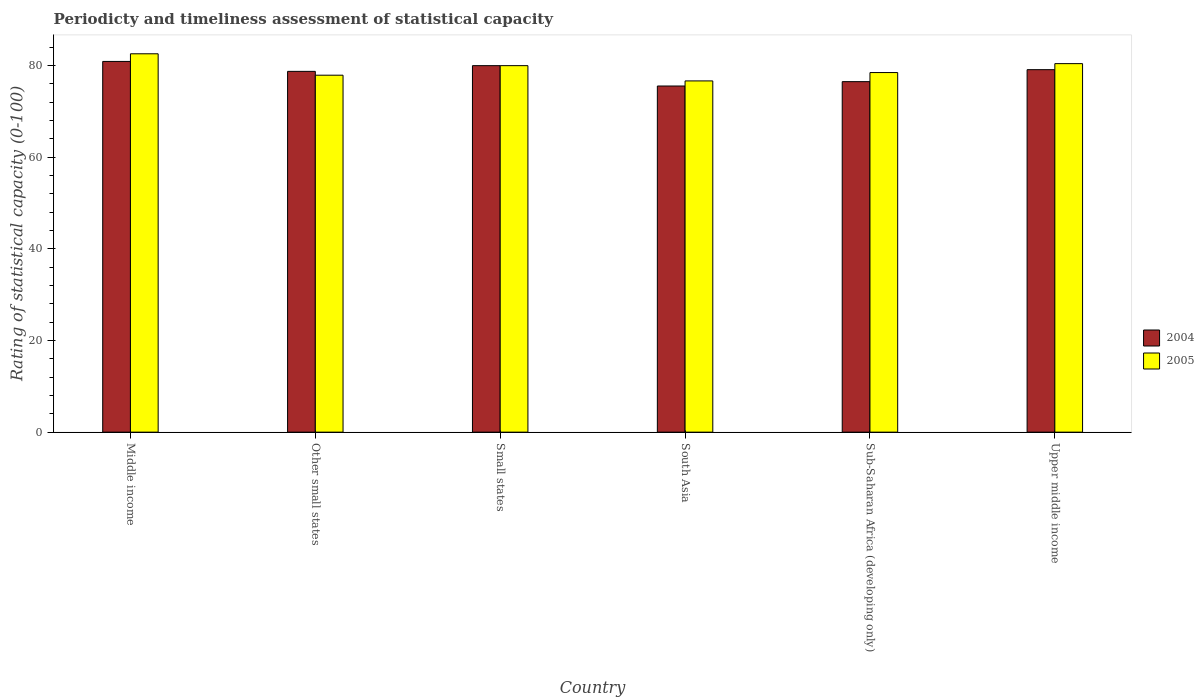How many different coloured bars are there?
Your response must be concise. 2. How many groups of bars are there?
Your answer should be very brief. 6. Are the number of bars per tick equal to the number of legend labels?
Offer a very short reply. Yes. Are the number of bars on each tick of the X-axis equal?
Provide a short and direct response. Yes. How many bars are there on the 1st tick from the right?
Provide a short and direct response. 2. What is the label of the 3rd group of bars from the left?
Give a very brief answer. Small states. What is the rating of statistical capacity in 2004 in Upper middle income?
Offer a very short reply. 79.12. Across all countries, what is the maximum rating of statistical capacity in 2004?
Ensure brevity in your answer.  80.92. Across all countries, what is the minimum rating of statistical capacity in 2005?
Ensure brevity in your answer.  76.67. In which country was the rating of statistical capacity in 2004 maximum?
Ensure brevity in your answer.  Middle income. In which country was the rating of statistical capacity in 2005 minimum?
Make the answer very short. South Asia. What is the total rating of statistical capacity in 2005 in the graph?
Your answer should be compact. 476.1. What is the difference between the rating of statistical capacity in 2004 in Small states and that in South Asia?
Ensure brevity in your answer.  4.44. What is the difference between the rating of statistical capacity in 2005 in Middle income and the rating of statistical capacity in 2004 in Small states?
Keep it short and to the point. 2.59. What is the average rating of statistical capacity in 2004 per country?
Your response must be concise. 78.48. What is the difference between the rating of statistical capacity of/in 2005 and rating of statistical capacity of/in 2004 in Small states?
Offer a very short reply. -9.999999974752427e-7. What is the ratio of the rating of statistical capacity in 2004 in Sub-Saharan Africa (developing only) to that in Upper middle income?
Your answer should be very brief. 0.97. Is the difference between the rating of statistical capacity in 2005 in Other small states and South Asia greater than the difference between the rating of statistical capacity in 2004 in Other small states and South Asia?
Provide a succinct answer. No. What is the difference between the highest and the second highest rating of statistical capacity in 2005?
Keep it short and to the point. -2.15. What is the difference between the highest and the lowest rating of statistical capacity in 2005?
Your answer should be very brief. 5.92. What does the 2nd bar from the left in Other small states represents?
Offer a terse response. 2005. How many bars are there?
Your answer should be compact. 12. Are all the bars in the graph horizontal?
Your answer should be very brief. No. How many countries are there in the graph?
Your answer should be compact. 6. Are the values on the major ticks of Y-axis written in scientific E-notation?
Your response must be concise. No. Does the graph contain any zero values?
Offer a very short reply. No. Does the graph contain grids?
Offer a terse response. No. Where does the legend appear in the graph?
Your answer should be very brief. Center right. How many legend labels are there?
Make the answer very short. 2. How are the legend labels stacked?
Your answer should be very brief. Vertical. What is the title of the graph?
Your answer should be compact. Periodicty and timeliness assessment of statistical capacity. Does "2002" appear as one of the legend labels in the graph?
Offer a terse response. No. What is the label or title of the Y-axis?
Keep it short and to the point. Rating of statistical capacity (0-100). What is the Rating of statistical capacity (0-100) of 2004 in Middle income?
Give a very brief answer. 80.92. What is the Rating of statistical capacity (0-100) in 2005 in Middle income?
Provide a succinct answer. 82.59. What is the Rating of statistical capacity (0-100) of 2004 in Other small states?
Your response must be concise. 78.75. What is the Rating of statistical capacity (0-100) in 2005 in Other small states?
Offer a very short reply. 77.92. What is the Rating of statistical capacity (0-100) of 2005 in Small states?
Keep it short and to the point. 80. What is the Rating of statistical capacity (0-100) in 2004 in South Asia?
Provide a succinct answer. 75.56. What is the Rating of statistical capacity (0-100) of 2005 in South Asia?
Give a very brief answer. 76.67. What is the Rating of statistical capacity (0-100) of 2004 in Sub-Saharan Africa (developing only)?
Your response must be concise. 76.51. What is the Rating of statistical capacity (0-100) in 2005 in Sub-Saharan Africa (developing only)?
Your response must be concise. 78.49. What is the Rating of statistical capacity (0-100) of 2004 in Upper middle income?
Provide a succinct answer. 79.12. What is the Rating of statistical capacity (0-100) in 2005 in Upper middle income?
Keep it short and to the point. 80.44. Across all countries, what is the maximum Rating of statistical capacity (0-100) in 2004?
Make the answer very short. 80.92. Across all countries, what is the maximum Rating of statistical capacity (0-100) in 2005?
Make the answer very short. 82.59. Across all countries, what is the minimum Rating of statistical capacity (0-100) of 2004?
Provide a succinct answer. 75.56. Across all countries, what is the minimum Rating of statistical capacity (0-100) in 2005?
Give a very brief answer. 76.67. What is the total Rating of statistical capacity (0-100) in 2004 in the graph?
Offer a very short reply. 470.86. What is the total Rating of statistical capacity (0-100) of 2005 in the graph?
Keep it short and to the point. 476.1. What is the difference between the Rating of statistical capacity (0-100) in 2004 in Middle income and that in Other small states?
Offer a terse response. 2.17. What is the difference between the Rating of statistical capacity (0-100) of 2005 in Middle income and that in Other small states?
Provide a short and direct response. 4.67. What is the difference between the Rating of statistical capacity (0-100) in 2004 in Middle income and that in Small states?
Offer a terse response. 0.92. What is the difference between the Rating of statistical capacity (0-100) of 2005 in Middle income and that in Small states?
Your answer should be compact. 2.59. What is the difference between the Rating of statistical capacity (0-100) in 2004 in Middle income and that in South Asia?
Keep it short and to the point. 5.37. What is the difference between the Rating of statistical capacity (0-100) of 2005 in Middle income and that in South Asia?
Your answer should be compact. 5.92. What is the difference between the Rating of statistical capacity (0-100) of 2004 in Middle income and that in Sub-Saharan Africa (developing only)?
Keep it short and to the point. 4.41. What is the difference between the Rating of statistical capacity (0-100) of 2005 in Middle income and that in Sub-Saharan Africa (developing only)?
Your answer should be very brief. 4.1. What is the difference between the Rating of statistical capacity (0-100) in 2004 in Middle income and that in Upper middle income?
Make the answer very short. 1.8. What is the difference between the Rating of statistical capacity (0-100) in 2005 in Middle income and that in Upper middle income?
Offer a very short reply. 2.15. What is the difference between the Rating of statistical capacity (0-100) of 2004 in Other small states and that in Small states?
Your response must be concise. -1.25. What is the difference between the Rating of statistical capacity (0-100) of 2005 in Other small states and that in Small states?
Provide a succinct answer. -2.08. What is the difference between the Rating of statistical capacity (0-100) of 2004 in Other small states and that in South Asia?
Provide a short and direct response. 3.19. What is the difference between the Rating of statistical capacity (0-100) of 2005 in Other small states and that in South Asia?
Make the answer very short. 1.25. What is the difference between the Rating of statistical capacity (0-100) of 2004 in Other small states and that in Sub-Saharan Africa (developing only)?
Your response must be concise. 2.24. What is the difference between the Rating of statistical capacity (0-100) in 2005 in Other small states and that in Sub-Saharan Africa (developing only)?
Offer a very short reply. -0.58. What is the difference between the Rating of statistical capacity (0-100) in 2004 in Other small states and that in Upper middle income?
Offer a very short reply. -0.37. What is the difference between the Rating of statistical capacity (0-100) of 2005 in Other small states and that in Upper middle income?
Keep it short and to the point. -2.52. What is the difference between the Rating of statistical capacity (0-100) of 2004 in Small states and that in South Asia?
Your answer should be compact. 4.44. What is the difference between the Rating of statistical capacity (0-100) in 2005 in Small states and that in South Asia?
Your answer should be compact. 3.33. What is the difference between the Rating of statistical capacity (0-100) of 2004 in Small states and that in Sub-Saharan Africa (developing only)?
Ensure brevity in your answer.  3.49. What is the difference between the Rating of statistical capacity (0-100) of 2005 in Small states and that in Sub-Saharan Africa (developing only)?
Give a very brief answer. 1.51. What is the difference between the Rating of statistical capacity (0-100) in 2004 in Small states and that in Upper middle income?
Keep it short and to the point. 0.88. What is the difference between the Rating of statistical capacity (0-100) in 2005 in Small states and that in Upper middle income?
Your answer should be very brief. -0.44. What is the difference between the Rating of statistical capacity (0-100) of 2004 in South Asia and that in Sub-Saharan Africa (developing only)?
Provide a short and direct response. -0.95. What is the difference between the Rating of statistical capacity (0-100) in 2005 in South Asia and that in Sub-Saharan Africa (developing only)?
Give a very brief answer. -1.83. What is the difference between the Rating of statistical capacity (0-100) in 2004 in South Asia and that in Upper middle income?
Your answer should be very brief. -3.57. What is the difference between the Rating of statistical capacity (0-100) of 2005 in South Asia and that in Upper middle income?
Provide a short and direct response. -3.77. What is the difference between the Rating of statistical capacity (0-100) of 2004 in Sub-Saharan Africa (developing only) and that in Upper middle income?
Offer a terse response. -2.61. What is the difference between the Rating of statistical capacity (0-100) in 2005 in Sub-Saharan Africa (developing only) and that in Upper middle income?
Give a very brief answer. -1.95. What is the difference between the Rating of statistical capacity (0-100) in 2004 in Middle income and the Rating of statistical capacity (0-100) in 2005 in Other small states?
Offer a terse response. 3. What is the difference between the Rating of statistical capacity (0-100) of 2004 in Middle income and the Rating of statistical capacity (0-100) of 2005 in Small states?
Keep it short and to the point. 0.92. What is the difference between the Rating of statistical capacity (0-100) of 2004 in Middle income and the Rating of statistical capacity (0-100) of 2005 in South Asia?
Your answer should be very brief. 4.25. What is the difference between the Rating of statistical capacity (0-100) of 2004 in Middle income and the Rating of statistical capacity (0-100) of 2005 in Sub-Saharan Africa (developing only)?
Your answer should be very brief. 2.43. What is the difference between the Rating of statistical capacity (0-100) of 2004 in Middle income and the Rating of statistical capacity (0-100) of 2005 in Upper middle income?
Provide a succinct answer. 0.48. What is the difference between the Rating of statistical capacity (0-100) in 2004 in Other small states and the Rating of statistical capacity (0-100) in 2005 in Small states?
Make the answer very short. -1.25. What is the difference between the Rating of statistical capacity (0-100) of 2004 in Other small states and the Rating of statistical capacity (0-100) of 2005 in South Asia?
Offer a very short reply. 2.08. What is the difference between the Rating of statistical capacity (0-100) in 2004 in Other small states and the Rating of statistical capacity (0-100) in 2005 in Sub-Saharan Africa (developing only)?
Offer a terse response. 0.26. What is the difference between the Rating of statistical capacity (0-100) of 2004 in Other small states and the Rating of statistical capacity (0-100) of 2005 in Upper middle income?
Make the answer very short. -1.69. What is the difference between the Rating of statistical capacity (0-100) in 2004 in Small states and the Rating of statistical capacity (0-100) in 2005 in Sub-Saharan Africa (developing only)?
Your response must be concise. 1.51. What is the difference between the Rating of statistical capacity (0-100) in 2004 in Small states and the Rating of statistical capacity (0-100) in 2005 in Upper middle income?
Provide a succinct answer. -0.44. What is the difference between the Rating of statistical capacity (0-100) of 2004 in South Asia and the Rating of statistical capacity (0-100) of 2005 in Sub-Saharan Africa (developing only)?
Keep it short and to the point. -2.94. What is the difference between the Rating of statistical capacity (0-100) of 2004 in South Asia and the Rating of statistical capacity (0-100) of 2005 in Upper middle income?
Ensure brevity in your answer.  -4.88. What is the difference between the Rating of statistical capacity (0-100) in 2004 in Sub-Saharan Africa (developing only) and the Rating of statistical capacity (0-100) in 2005 in Upper middle income?
Your answer should be compact. -3.93. What is the average Rating of statistical capacity (0-100) of 2004 per country?
Provide a short and direct response. 78.48. What is the average Rating of statistical capacity (0-100) of 2005 per country?
Make the answer very short. 79.35. What is the difference between the Rating of statistical capacity (0-100) of 2004 and Rating of statistical capacity (0-100) of 2005 in Middle income?
Keep it short and to the point. -1.67. What is the difference between the Rating of statistical capacity (0-100) of 2004 and Rating of statistical capacity (0-100) of 2005 in South Asia?
Offer a very short reply. -1.11. What is the difference between the Rating of statistical capacity (0-100) in 2004 and Rating of statistical capacity (0-100) in 2005 in Sub-Saharan Africa (developing only)?
Your answer should be very brief. -1.98. What is the difference between the Rating of statistical capacity (0-100) in 2004 and Rating of statistical capacity (0-100) in 2005 in Upper middle income?
Provide a short and direct response. -1.32. What is the ratio of the Rating of statistical capacity (0-100) of 2004 in Middle income to that in Other small states?
Your answer should be very brief. 1.03. What is the ratio of the Rating of statistical capacity (0-100) of 2005 in Middle income to that in Other small states?
Offer a terse response. 1.06. What is the ratio of the Rating of statistical capacity (0-100) in 2004 in Middle income to that in Small states?
Give a very brief answer. 1.01. What is the ratio of the Rating of statistical capacity (0-100) in 2005 in Middle income to that in Small states?
Provide a short and direct response. 1.03. What is the ratio of the Rating of statistical capacity (0-100) of 2004 in Middle income to that in South Asia?
Provide a short and direct response. 1.07. What is the ratio of the Rating of statistical capacity (0-100) in 2005 in Middle income to that in South Asia?
Your answer should be compact. 1.08. What is the ratio of the Rating of statistical capacity (0-100) of 2004 in Middle income to that in Sub-Saharan Africa (developing only)?
Offer a very short reply. 1.06. What is the ratio of the Rating of statistical capacity (0-100) of 2005 in Middle income to that in Sub-Saharan Africa (developing only)?
Give a very brief answer. 1.05. What is the ratio of the Rating of statistical capacity (0-100) in 2004 in Middle income to that in Upper middle income?
Keep it short and to the point. 1.02. What is the ratio of the Rating of statistical capacity (0-100) in 2005 in Middle income to that in Upper middle income?
Give a very brief answer. 1.03. What is the ratio of the Rating of statistical capacity (0-100) of 2004 in Other small states to that in Small states?
Your response must be concise. 0.98. What is the ratio of the Rating of statistical capacity (0-100) in 2004 in Other small states to that in South Asia?
Offer a very short reply. 1.04. What is the ratio of the Rating of statistical capacity (0-100) in 2005 in Other small states to that in South Asia?
Offer a very short reply. 1.02. What is the ratio of the Rating of statistical capacity (0-100) of 2004 in Other small states to that in Sub-Saharan Africa (developing only)?
Offer a very short reply. 1.03. What is the ratio of the Rating of statistical capacity (0-100) in 2004 in Other small states to that in Upper middle income?
Your answer should be compact. 1. What is the ratio of the Rating of statistical capacity (0-100) in 2005 in Other small states to that in Upper middle income?
Make the answer very short. 0.97. What is the ratio of the Rating of statistical capacity (0-100) in 2004 in Small states to that in South Asia?
Your answer should be compact. 1.06. What is the ratio of the Rating of statistical capacity (0-100) in 2005 in Small states to that in South Asia?
Your answer should be compact. 1.04. What is the ratio of the Rating of statistical capacity (0-100) in 2004 in Small states to that in Sub-Saharan Africa (developing only)?
Offer a terse response. 1.05. What is the ratio of the Rating of statistical capacity (0-100) of 2005 in Small states to that in Sub-Saharan Africa (developing only)?
Keep it short and to the point. 1.02. What is the ratio of the Rating of statistical capacity (0-100) of 2004 in Small states to that in Upper middle income?
Your answer should be very brief. 1.01. What is the ratio of the Rating of statistical capacity (0-100) of 2005 in Small states to that in Upper middle income?
Ensure brevity in your answer.  0.99. What is the ratio of the Rating of statistical capacity (0-100) of 2004 in South Asia to that in Sub-Saharan Africa (developing only)?
Ensure brevity in your answer.  0.99. What is the ratio of the Rating of statistical capacity (0-100) of 2005 in South Asia to that in Sub-Saharan Africa (developing only)?
Give a very brief answer. 0.98. What is the ratio of the Rating of statistical capacity (0-100) of 2004 in South Asia to that in Upper middle income?
Ensure brevity in your answer.  0.95. What is the ratio of the Rating of statistical capacity (0-100) of 2005 in South Asia to that in Upper middle income?
Give a very brief answer. 0.95. What is the ratio of the Rating of statistical capacity (0-100) of 2005 in Sub-Saharan Africa (developing only) to that in Upper middle income?
Your response must be concise. 0.98. What is the difference between the highest and the second highest Rating of statistical capacity (0-100) in 2004?
Your response must be concise. 0.92. What is the difference between the highest and the second highest Rating of statistical capacity (0-100) of 2005?
Your answer should be compact. 2.15. What is the difference between the highest and the lowest Rating of statistical capacity (0-100) in 2004?
Give a very brief answer. 5.37. What is the difference between the highest and the lowest Rating of statistical capacity (0-100) in 2005?
Provide a short and direct response. 5.92. 